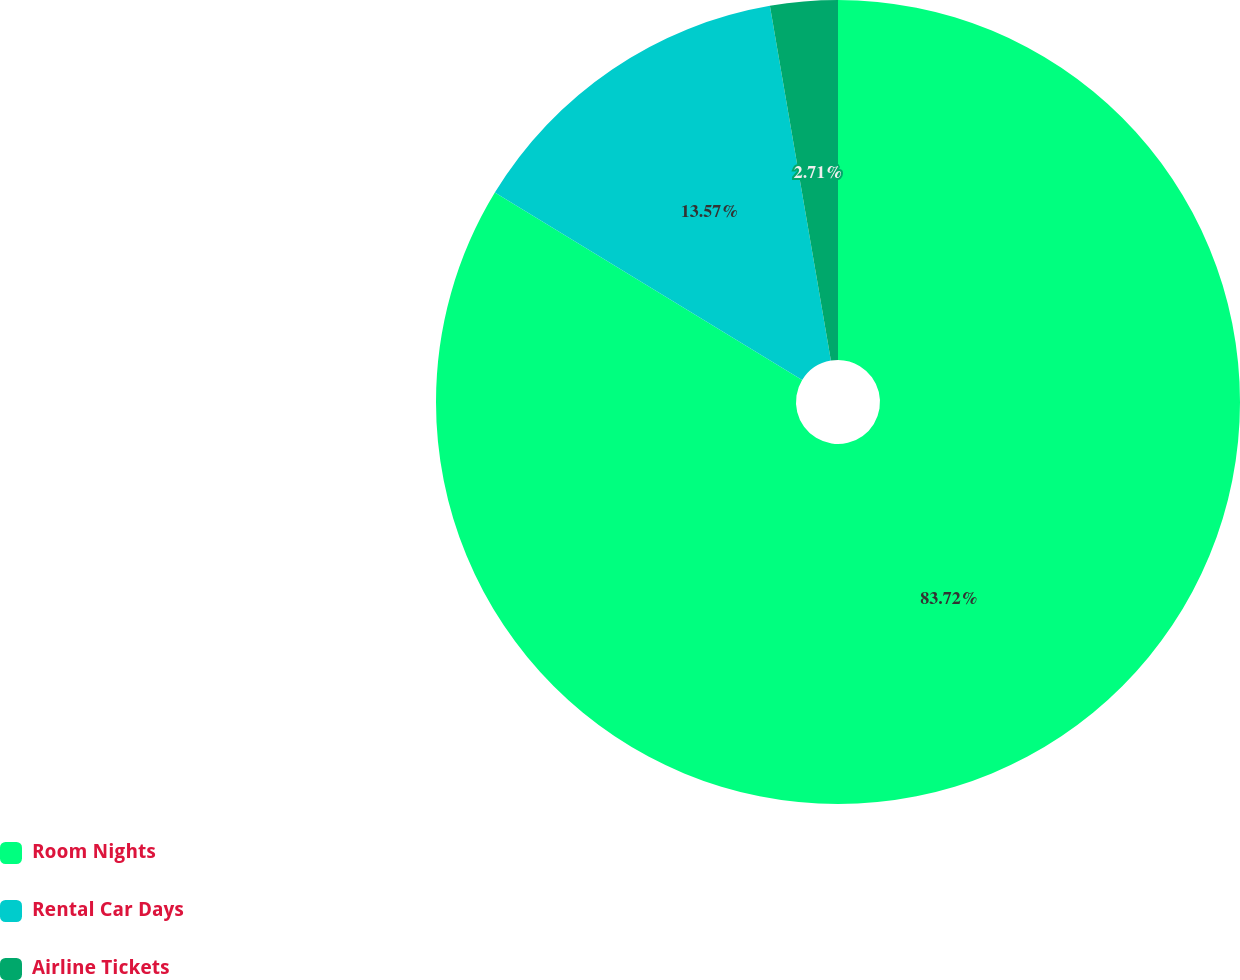<chart> <loc_0><loc_0><loc_500><loc_500><pie_chart><fcel>Room Nights<fcel>Rental Car Days<fcel>Airline Tickets<nl><fcel>83.72%<fcel>13.57%<fcel>2.71%<nl></chart> 